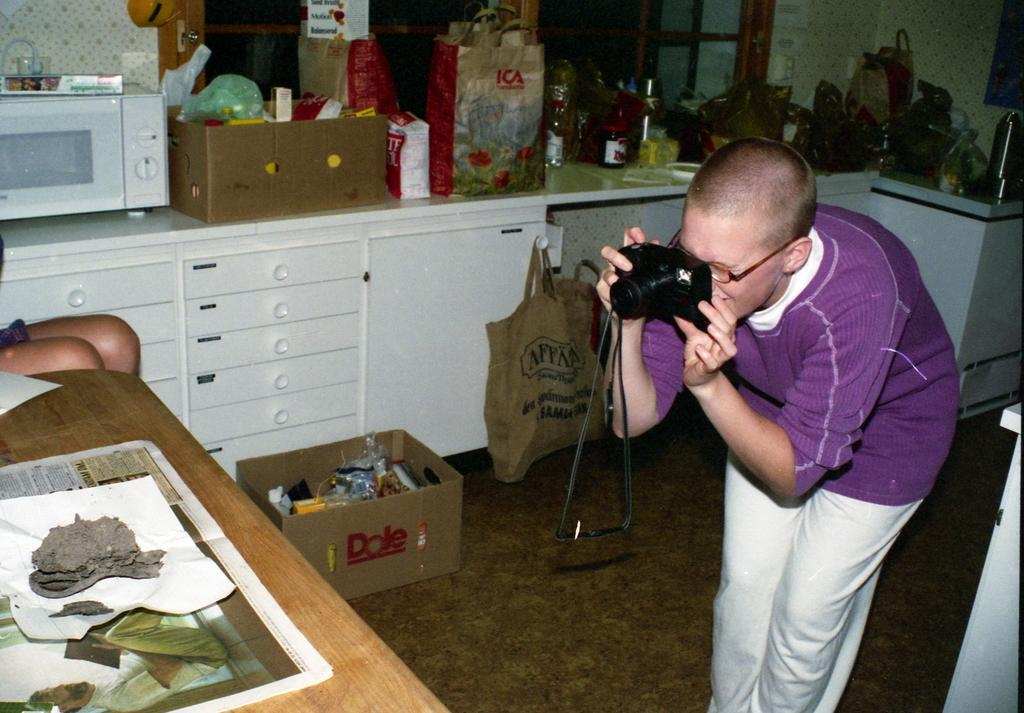<image>
Offer a succinct explanation of the picture presented. A man takes a photo of some items on a table and there is a Dole box in the background. 